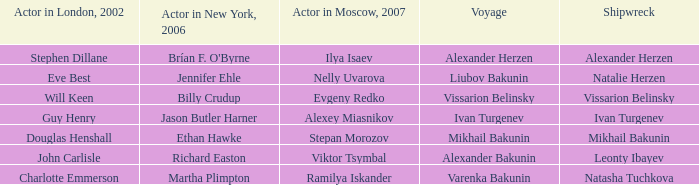In 2002, which actor was involved in the shipwreck of leonty ibayev in london? John Carlisle. 